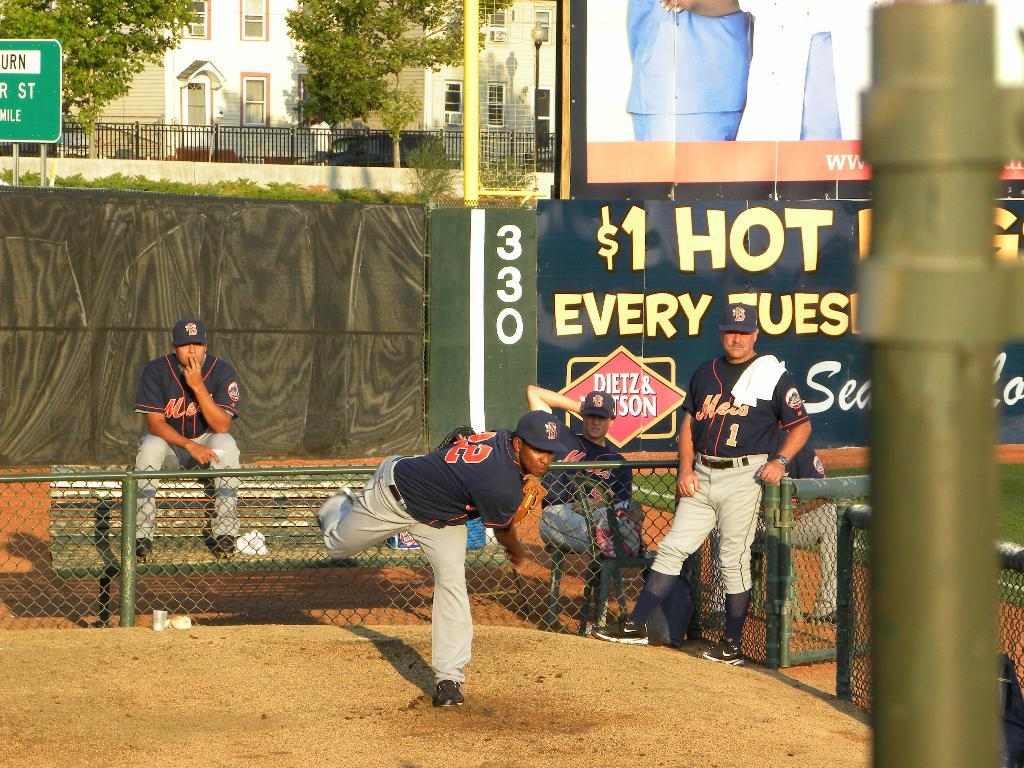Provide a one-sentence caption for the provided image. Hot dogs can be bought for $1 at this baseball game. 